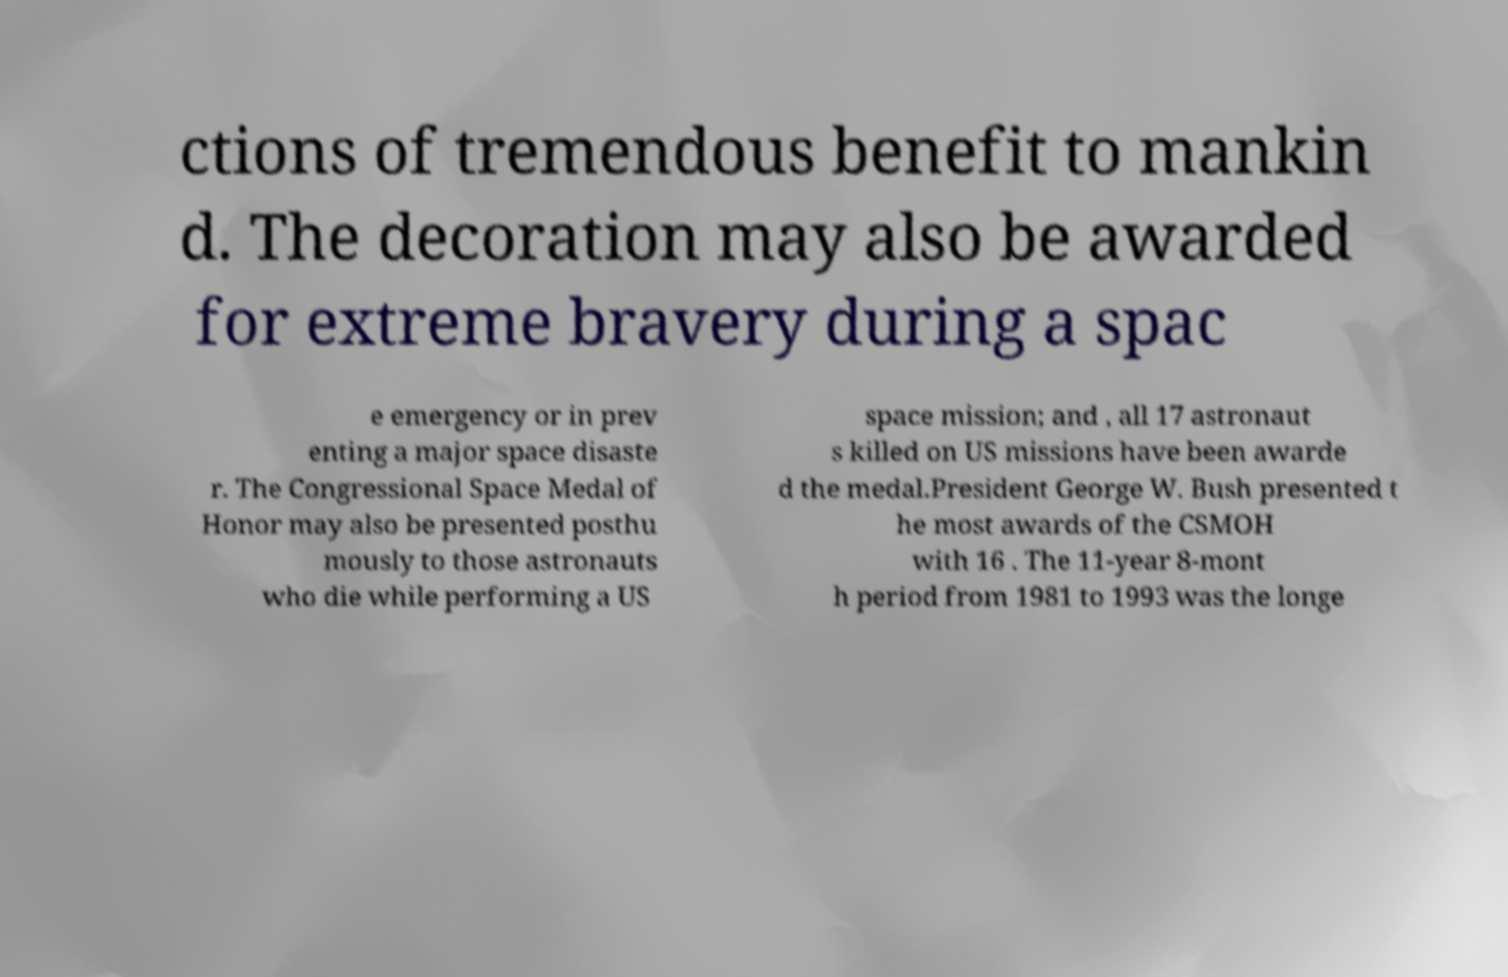For documentation purposes, I need the text within this image transcribed. Could you provide that? ctions of tremendous benefit to mankin d. The decoration may also be awarded for extreme bravery during a spac e emergency or in prev enting a major space disaste r. The Congressional Space Medal of Honor may also be presented posthu mously to those astronauts who die while performing a US space mission; and , all 17 astronaut s killed on US missions have been awarde d the medal.President George W. Bush presented t he most awards of the CSMOH with 16 . The 11-year 8-mont h period from 1981 to 1993 was the longe 